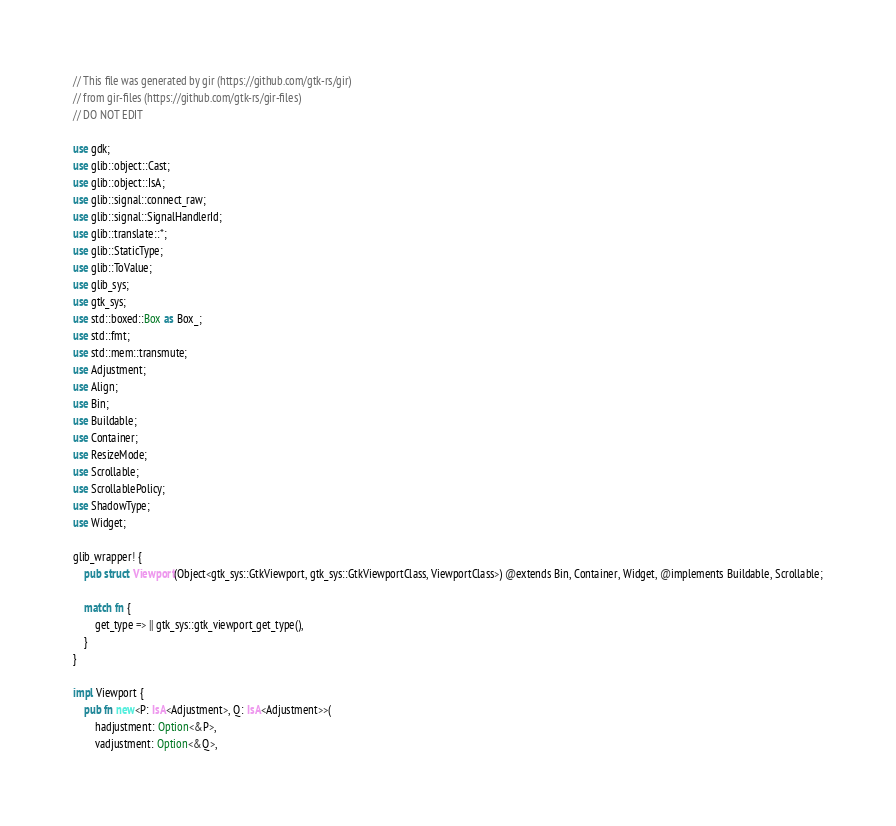Convert code to text. <code><loc_0><loc_0><loc_500><loc_500><_Rust_>// This file was generated by gir (https://github.com/gtk-rs/gir)
// from gir-files (https://github.com/gtk-rs/gir-files)
// DO NOT EDIT

use gdk;
use glib::object::Cast;
use glib::object::IsA;
use glib::signal::connect_raw;
use glib::signal::SignalHandlerId;
use glib::translate::*;
use glib::StaticType;
use glib::ToValue;
use glib_sys;
use gtk_sys;
use std::boxed::Box as Box_;
use std::fmt;
use std::mem::transmute;
use Adjustment;
use Align;
use Bin;
use Buildable;
use Container;
use ResizeMode;
use Scrollable;
use ScrollablePolicy;
use ShadowType;
use Widget;

glib_wrapper! {
    pub struct Viewport(Object<gtk_sys::GtkViewport, gtk_sys::GtkViewportClass, ViewportClass>) @extends Bin, Container, Widget, @implements Buildable, Scrollable;

    match fn {
        get_type => || gtk_sys::gtk_viewport_get_type(),
    }
}

impl Viewport {
    pub fn new<P: IsA<Adjustment>, Q: IsA<Adjustment>>(
        hadjustment: Option<&P>,
        vadjustment: Option<&Q>,</code> 